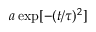Convert formula to latex. <formula><loc_0><loc_0><loc_500><loc_500>a \exp [ - ( t / \tau ) ^ { 2 } ]</formula> 